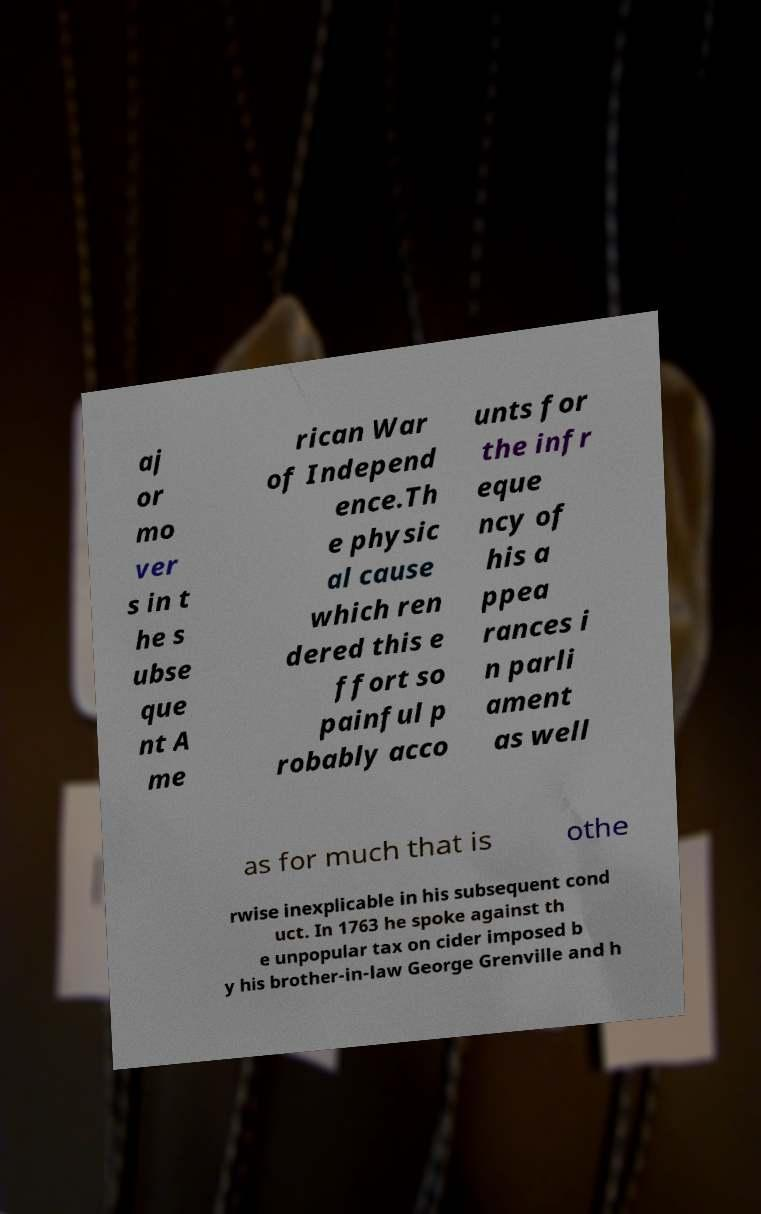Can you accurately transcribe the text from the provided image for me? aj or mo ver s in t he s ubse que nt A me rican War of Independ ence.Th e physic al cause which ren dered this e ffort so painful p robably acco unts for the infr eque ncy of his a ppea rances i n parli ament as well as for much that is othe rwise inexplicable in his subsequent cond uct. In 1763 he spoke against th e unpopular tax on cider imposed b y his brother-in-law George Grenville and h 